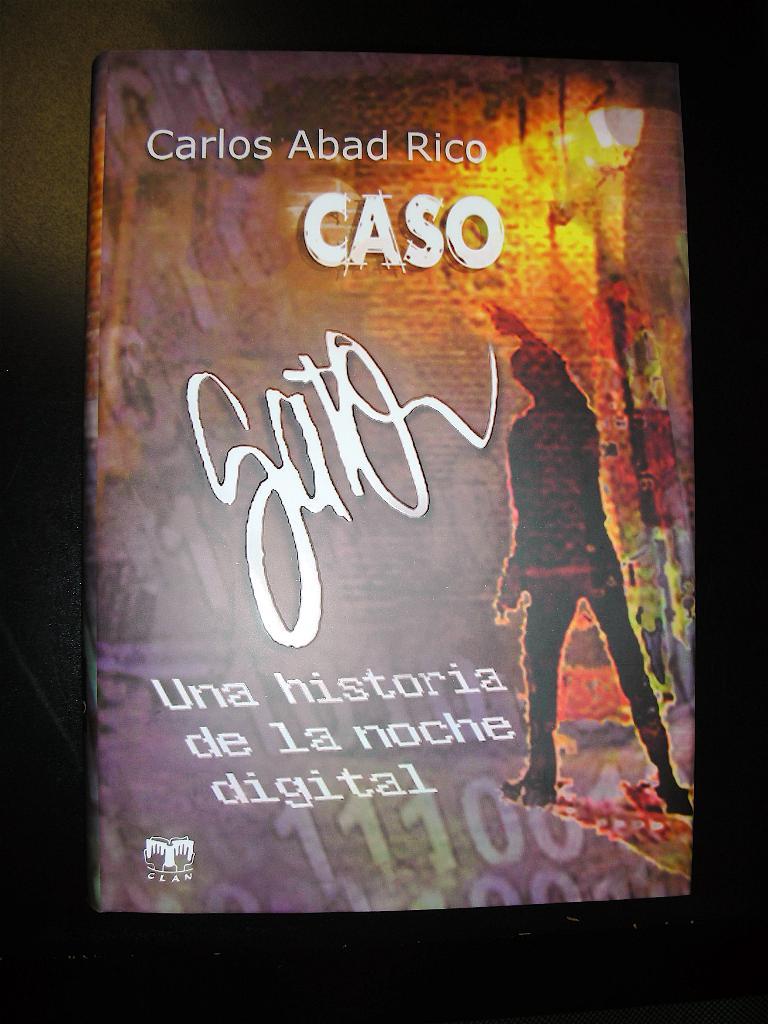Who wrote this?
Offer a very short reply. Carlos abad rico. Who authored the book?
Offer a terse response. Carlos abad rico. 